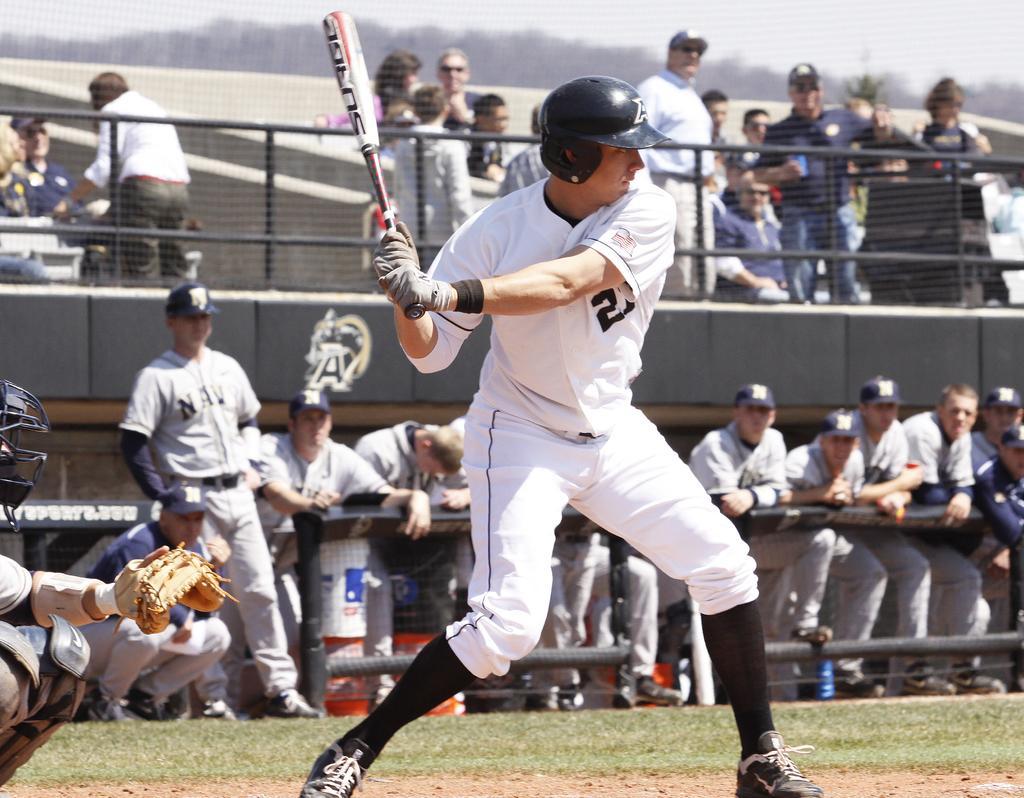Describe this image in one or two sentences. In the center of the image there is a person holding a baseball bat. In the background of the image there are people standing in stands. 